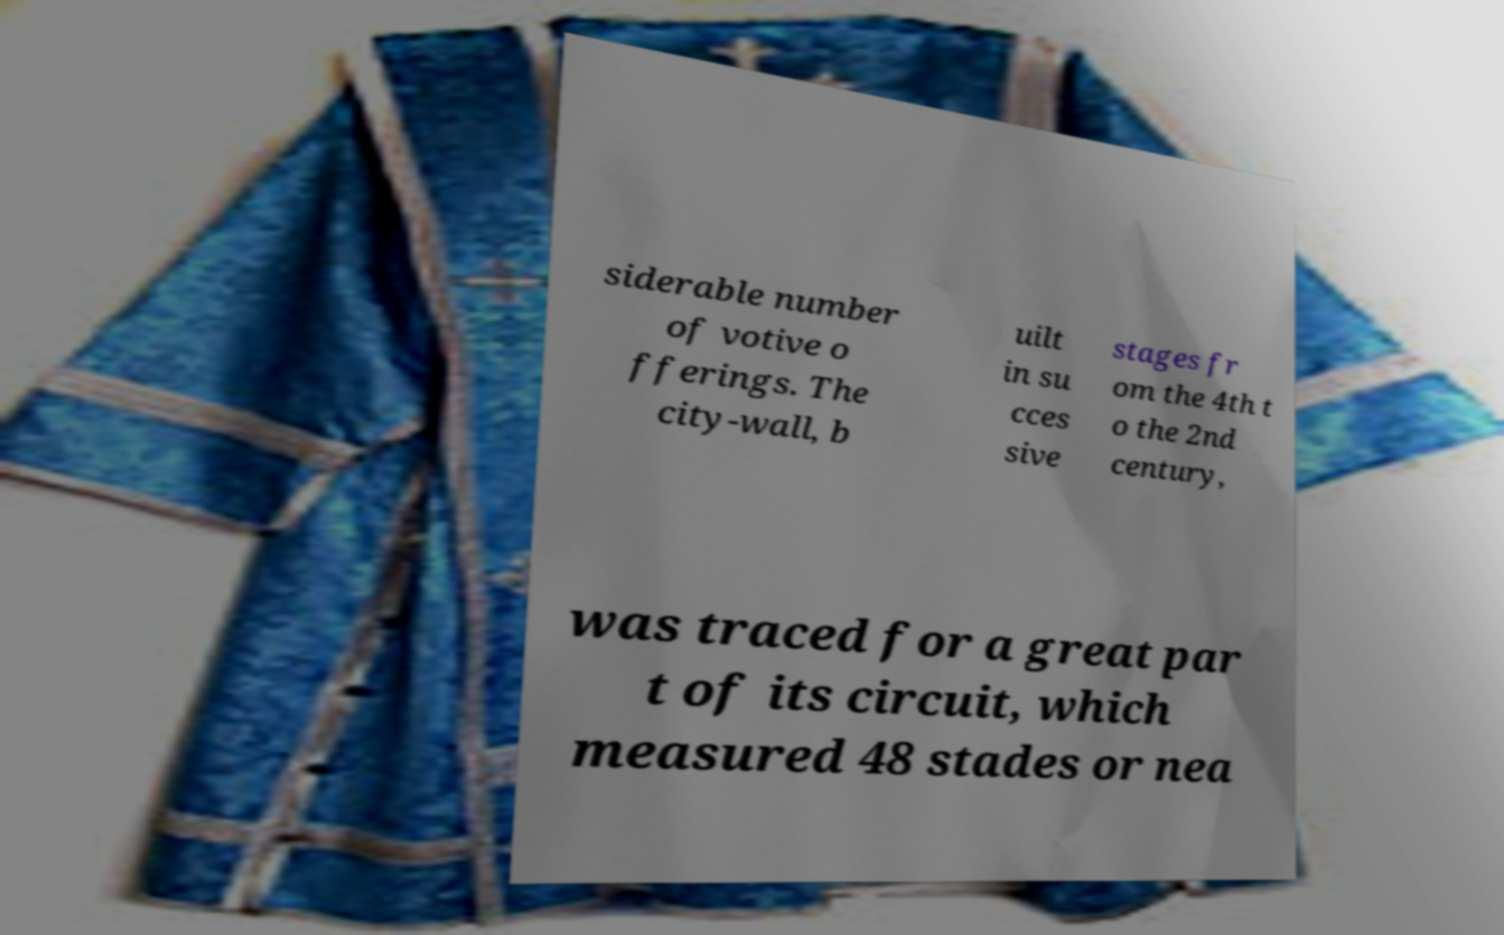There's text embedded in this image that I need extracted. Can you transcribe it verbatim? siderable number of votive o fferings. The city-wall, b uilt in su cces sive stages fr om the 4th t o the 2nd century, was traced for a great par t of its circuit, which measured 48 stades or nea 